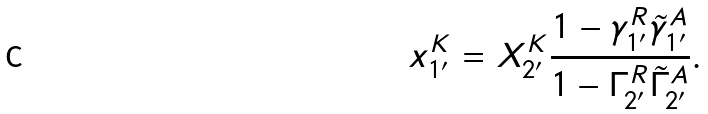<formula> <loc_0><loc_0><loc_500><loc_500>x _ { 1 ^ { \prime } } ^ { K } = X _ { 2 ^ { \prime } } ^ { K } \frac { 1 - \gamma _ { 1 ^ { \prime } } ^ { R } \tilde { \gamma } _ { 1 ^ { \prime } } ^ { A } } { 1 - \Gamma _ { 2 ^ { \prime } } ^ { R } \tilde { \Gamma } _ { 2 ^ { \prime } } ^ { A } } .</formula> 